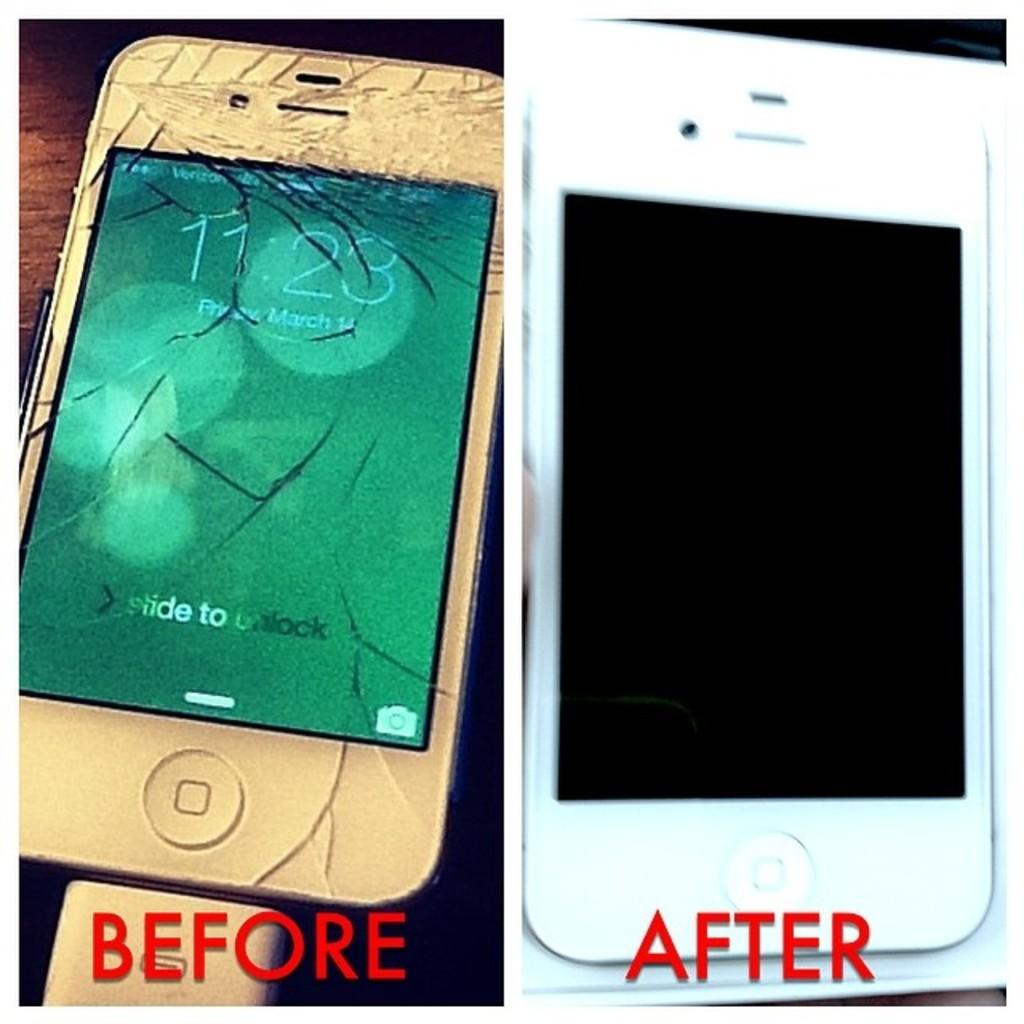What is the condition of the mobile phone on the left side of the image? There is a cracked mobile phone in the image. What is the condition of the mobile phone on the right side of the image? There is a new mobile phone in the image. What can be seen in addition to the mobile phones in the image? There is text visible in the image. What type of harmony can be heard in the background of the image? There is no audible harmony present in the image, as it is a still image and not a video or audio recording. 